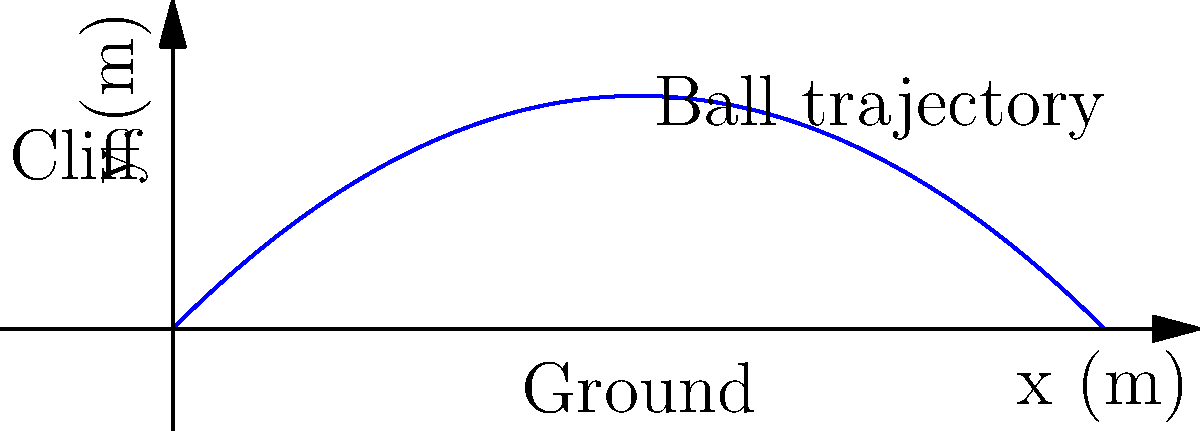As a psychotherapist contemplating a career change, you've decided to explore physics concepts to broaden your horizons. Consider a ball thrown from a cliff with an initial velocity of $20$ m/s at an angle of $45°$ above the horizontal. Assuming no air resistance, what is the maximum height reached by the ball? (Use $g = 9.8$ m/s²) Let's approach this step-by-step:

1) The maximum height is reached when the vertical component of velocity becomes zero.

2) We can use the equation: $v_y = v_0 \sin \theta - gt$

3) At the highest point, $v_y = 0$, so:
   $0 = v_0 \sin \theta - gt_{\text{max}}$

4) Solving for $t_{\text{max}}$:
   $t_{\text{max}} = \frac{v_0 \sin \theta}{g}$

5) Given:
   $v_0 = 20$ m/s
   $\theta = 45°$
   $g = 9.8$ m/s²

6) Calculate $t_{\text{max}}$:
   $t_{\text{max}} = \frac{20 \sin 45°}{9.8} = \frac{20 \cdot 0.707}{9.8} = 1.44$ s

7) Now use the equation for height: $y = v_0 \sin \theta \cdot t - \frac{1}{2}gt^2$

8) Substitute $t_{\text{max}}$:
   $y_{\text{max}} = 20 \sin 45° \cdot 1.44 - \frac{1}{2} \cdot 9.8 \cdot 1.44^2$

9) Simplify:
   $y_{\text{max}} = 20 \cdot 0.707 \cdot 1.44 - 4.9 \cdot 2.07$
   $y_{\text{max}} = 20.36 - 10.14 = 10.22$ m
Answer: $10.22$ m 